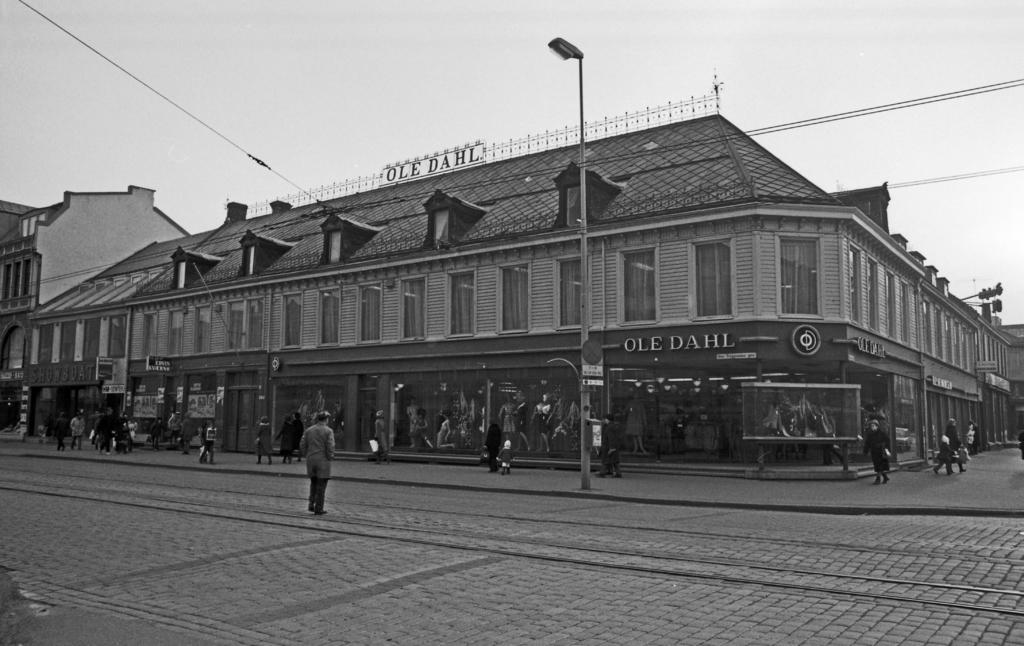What is the color scheme of the image? The image is black and white. What is the person in the image doing? There is a person walking in the image. What object can be seen in the image besides the person? There is a board in the image. What type of structure is visible in the image? There is a light on a pole in the image. What can be seen in the distance in the image? There are buildings, people, wires, and the sky visible in the background of the image. How many chairs are placed around the seed in the image? There are no chairs or seeds present in the image. What type of root can be seen growing from the person walking in the image? There are no roots visible in the image, and the person is walking, not growing. 